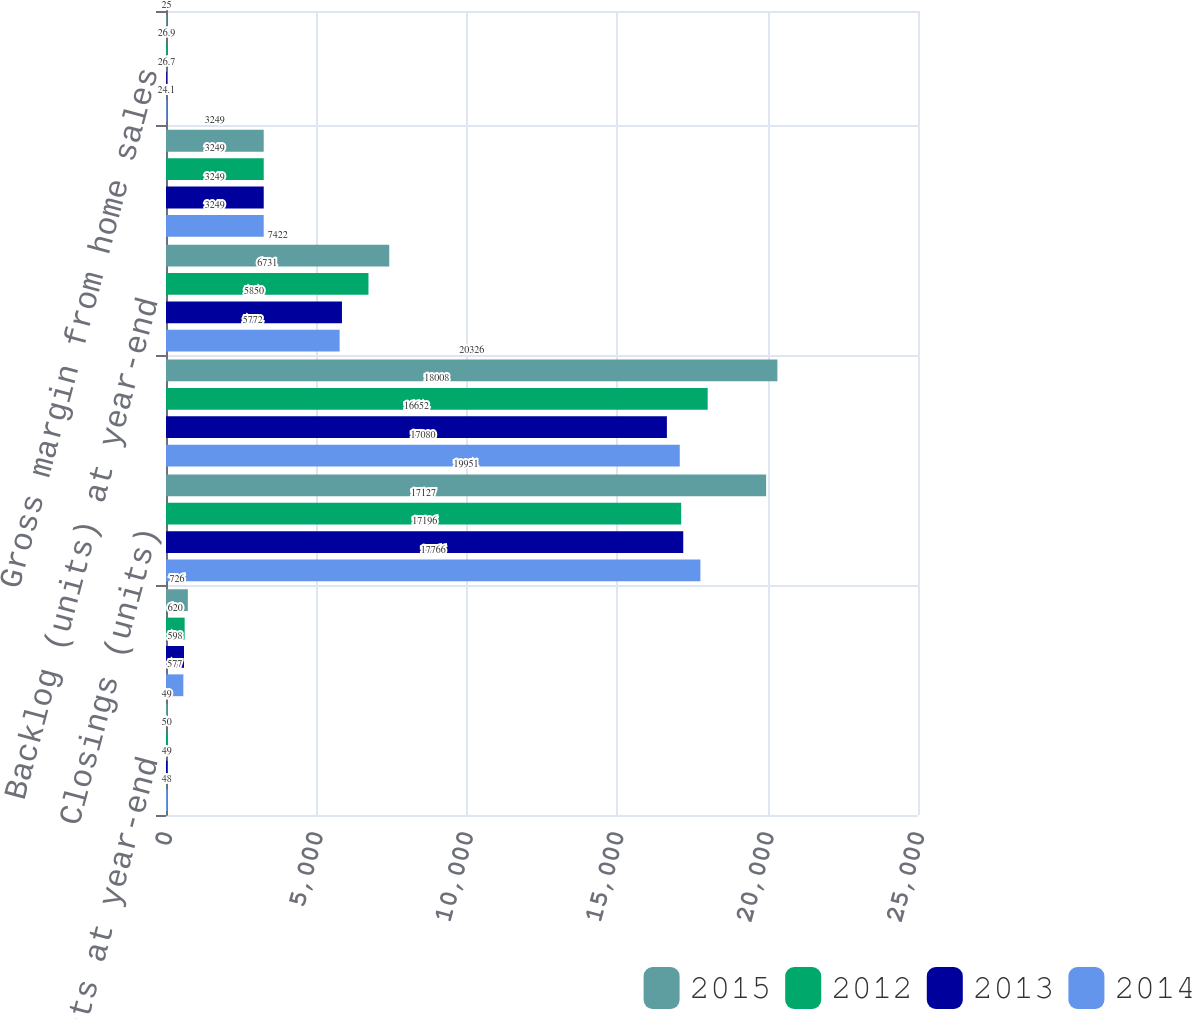Convert chart. <chart><loc_0><loc_0><loc_500><loc_500><stacked_bar_chart><ecel><fcel>Markets at year-end<fcel>Active communities at year-end<fcel>Closings (units)<fcel>Net new orders (units)<fcel>Backlog (units) at year-end<fcel>Average selling price (per<fcel>Gross margin from home sales<nl><fcel>2015<fcel>49<fcel>726<fcel>19951<fcel>20326<fcel>7422<fcel>3249<fcel>25<nl><fcel>2012<fcel>50<fcel>620<fcel>17127<fcel>18008<fcel>6731<fcel>3249<fcel>26.9<nl><fcel>2013<fcel>49<fcel>598<fcel>17196<fcel>16652<fcel>5850<fcel>3249<fcel>26.7<nl><fcel>2014<fcel>48<fcel>577<fcel>17766<fcel>17080<fcel>5772<fcel>3249<fcel>24.1<nl></chart> 